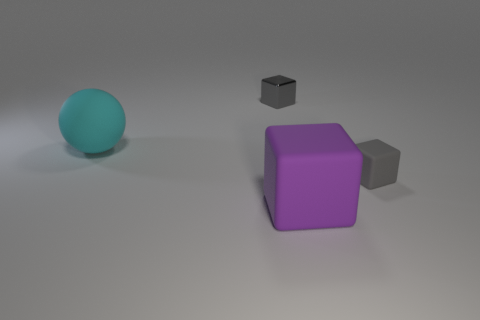There is a gray matte object; are there any gray matte things in front of it?
Your answer should be very brief. No. What is the color of the big thing that is behind the tiny object that is on the right side of the small gray shiny cube to the left of the tiny gray matte block?
Your answer should be compact. Cyan. What number of objects are both on the left side of the small gray metallic object and in front of the gray rubber object?
Provide a short and direct response. 0. How many cubes are either small objects or large cyan matte things?
Provide a short and direct response. 2. Are any large cyan spheres visible?
Your answer should be very brief. Yes. What number of other things are there of the same material as the ball
Make the answer very short. 2. There is a cube that is the same size as the ball; what material is it?
Your response must be concise. Rubber. Does the small thing behind the small gray rubber block have the same shape as the purple rubber thing?
Provide a succinct answer. Yes. Is the color of the big rubber ball the same as the small metallic thing?
Your response must be concise. No. How many things are matte objects that are in front of the tiny gray rubber cube or big rubber balls?
Your response must be concise. 2. 